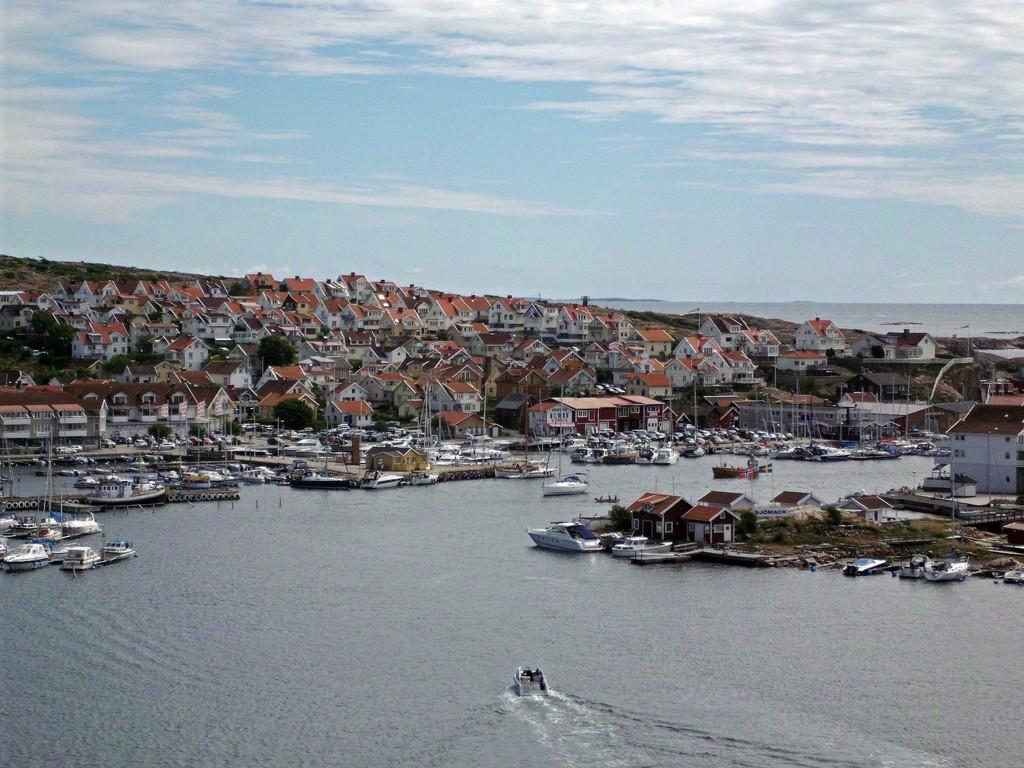What types of watercraft are present in the image? There are boats and ships in the image. Where are the boats and ships located? They are on a river in the image. What can be seen in the background of the image? There are buildings and the sky visible in the background of the image. What type of band is performing on the river in the image? There is no band present in the image; it features boats and ships on a river with buildings and the sky in the background. Who is the expert in the image providing guidance on watercraft navigation? There is no expert present in the image; it simply shows boats and ships on a river with buildings and the sky in the background. 